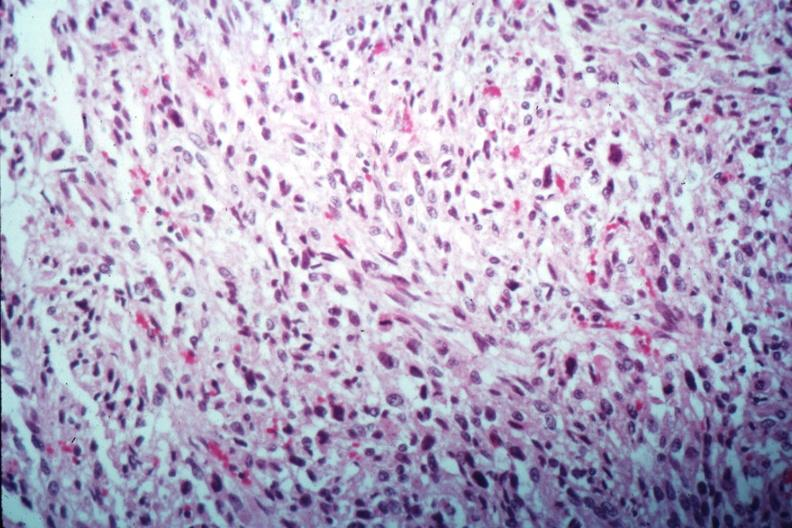s vessel present?
Answer the question using a single word or phrase. No 